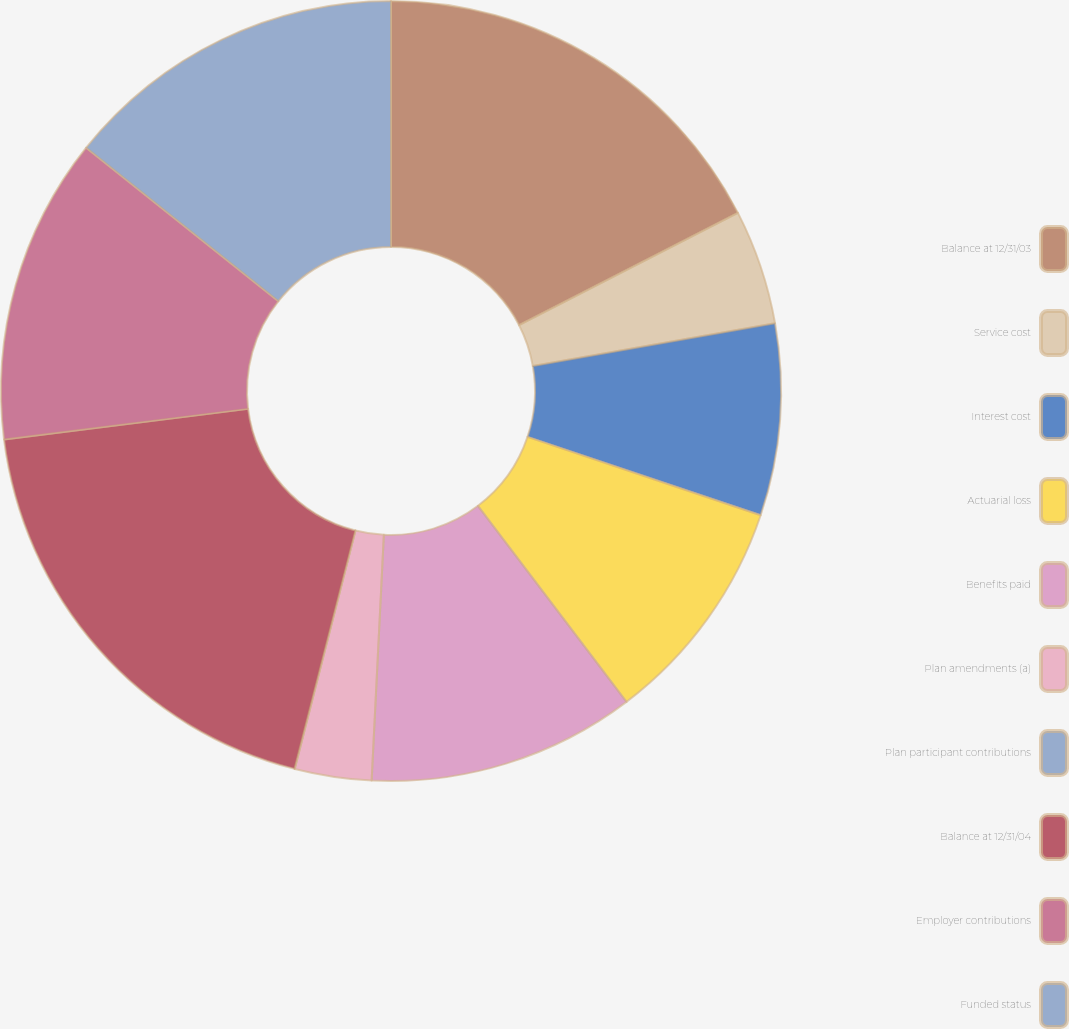<chart> <loc_0><loc_0><loc_500><loc_500><pie_chart><fcel>Balance at 12/31/03<fcel>Service cost<fcel>Interest cost<fcel>Actuarial loss<fcel>Benefits paid<fcel>Plan amendments (a)<fcel>Plan participant contributions<fcel>Balance at 12/31/04<fcel>Employer contributions<fcel>Funded status<nl><fcel>17.45%<fcel>4.77%<fcel>7.94%<fcel>9.52%<fcel>11.11%<fcel>3.18%<fcel>0.01%<fcel>19.04%<fcel>12.7%<fcel>14.28%<nl></chart> 